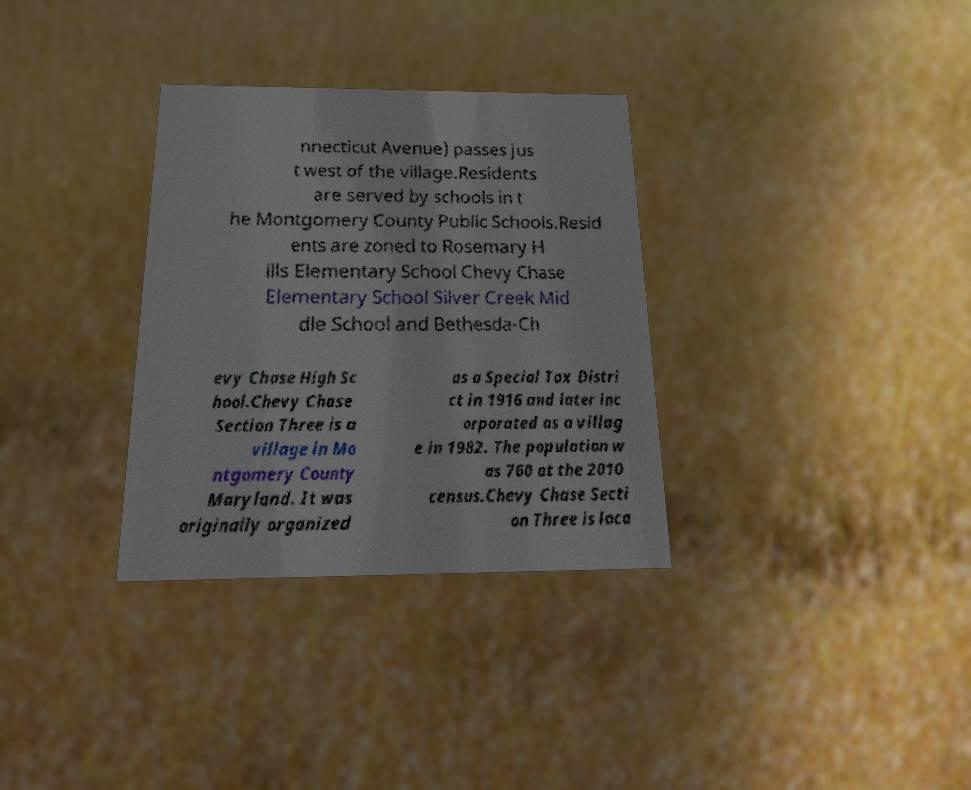Please read and relay the text visible in this image. What does it say? nnecticut Avenue) passes jus t west of the village.Residents are served by schools in t he Montgomery County Public Schools.Resid ents are zoned to Rosemary H ills Elementary School Chevy Chase Elementary School Silver Creek Mid dle School and Bethesda-Ch evy Chase High Sc hool.Chevy Chase Section Three is a village in Mo ntgomery County Maryland. It was originally organized as a Special Tax Distri ct in 1916 and later inc orporated as a villag e in 1982. The population w as 760 at the 2010 census.Chevy Chase Secti on Three is loca 